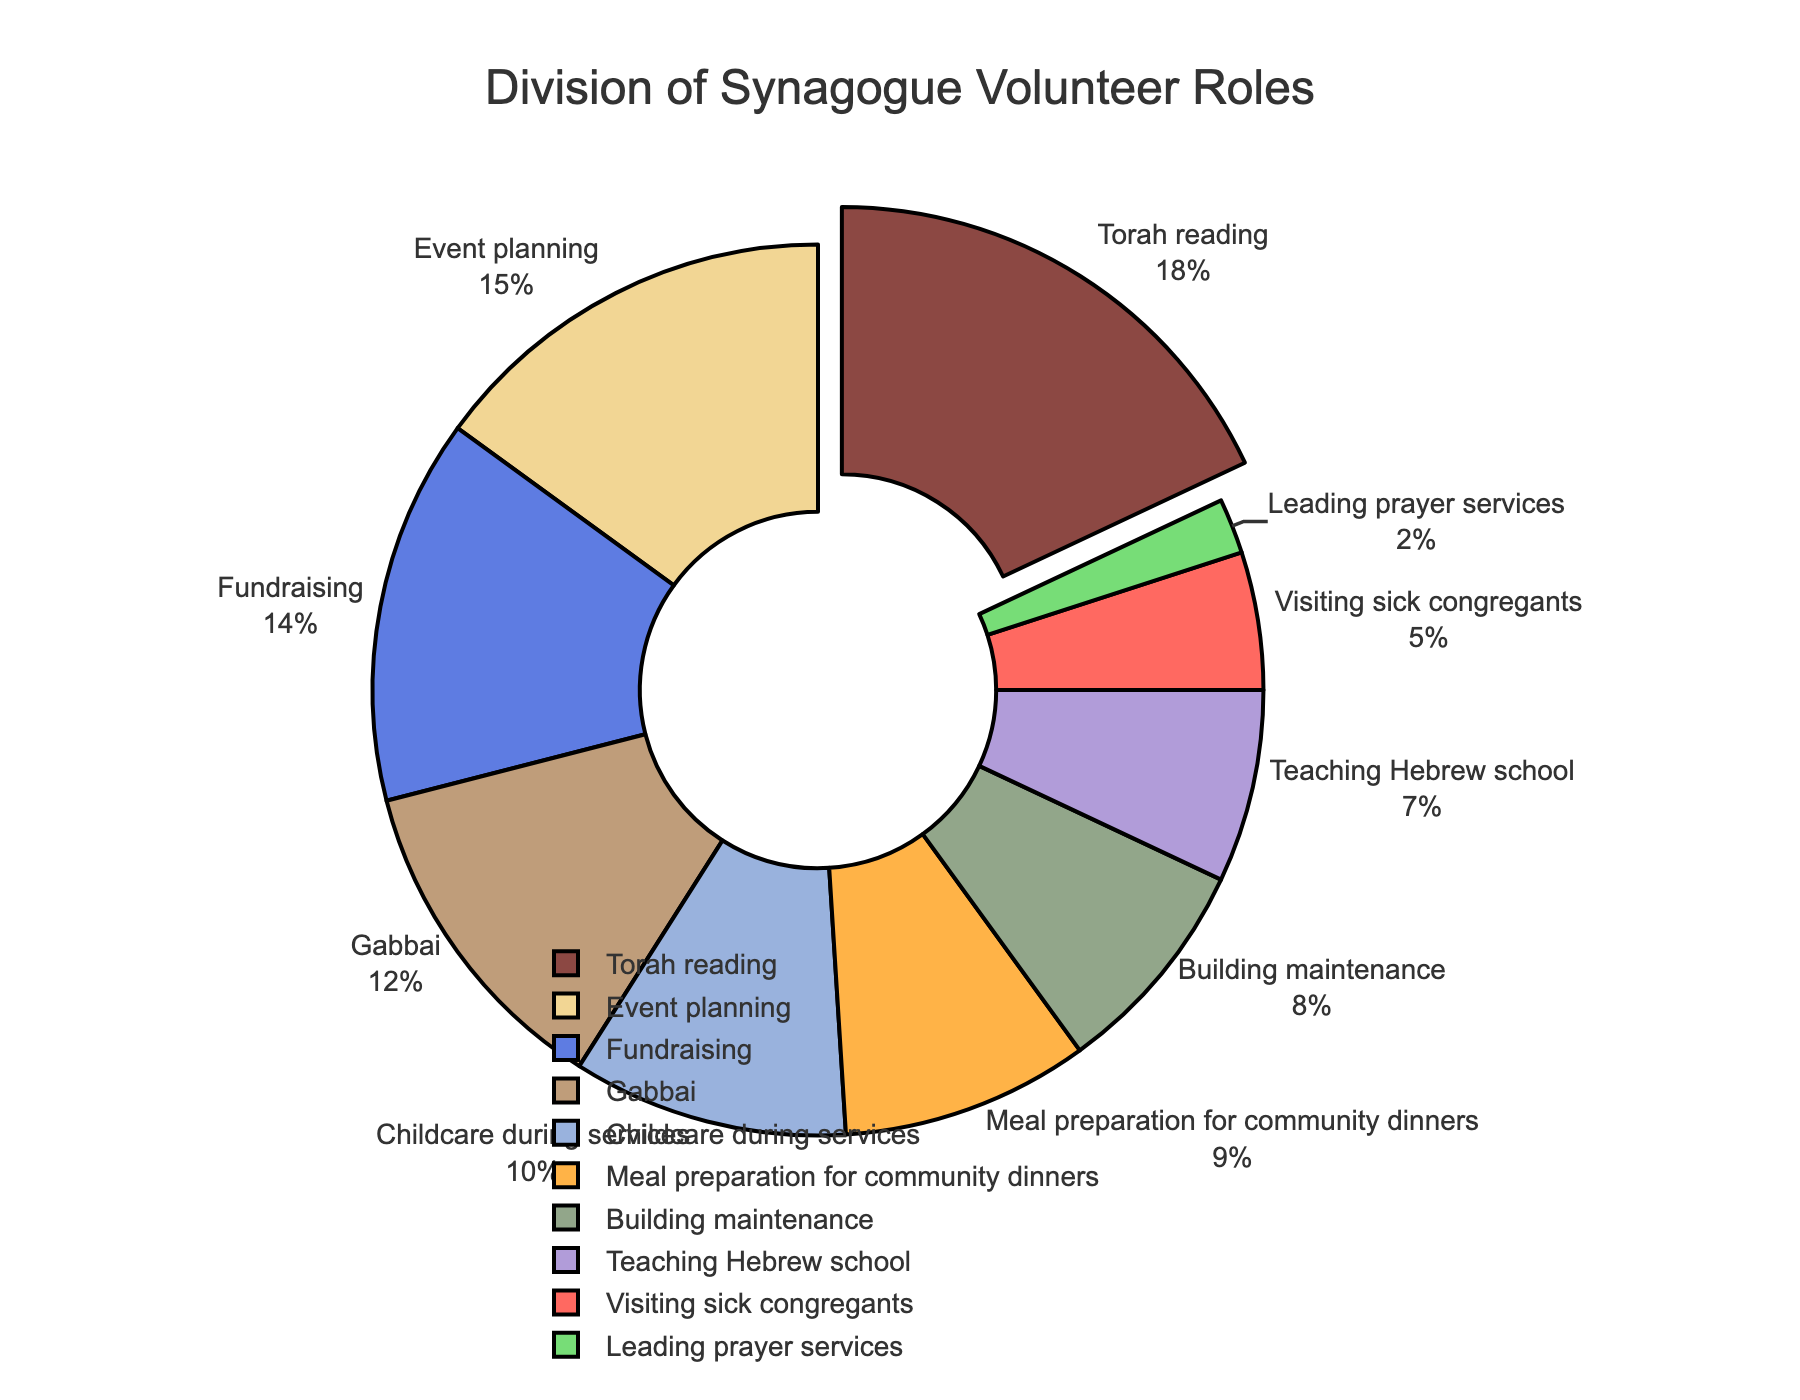What role has the highest percentage of volunteer participation? The segment with the largest pull-out in the pie chart represents the role with the highest percentage. In this case, it is Torah reading.
Answer: Torah reading What is the combined percentage of volunteers in Gabbai and Event planning? Add the percentages of Gabbai (12%) and Event planning (15%). 12 + 15 = 27
Answer: 27% Which role has the smallest slice in the pie chart, and what percentage does it represent? Identify the smallest visible slice in the pie chart, which corresponds to Leading prayer services. The percentage shown is 2%.
Answer: Leading prayer services, 2% Are there more volunteers in Fundraising or in Childcare during services? Compare the percentage segments of Fundraising (14%) and Childcare during services (10%). Fundraising has a higher percentage.
Answer: Fundraising What is the total percentage of volunteers in roles related to education (Teaching Hebrew school and Torah reading)? Add the percentages of Teaching Hebrew school (7%) and Torah reading (18%). 7 + 18 = 25
Answer: 25% Which roles together make up exactly 23% of the volunteer efforts? Identify the percentages of each role and sum them up to reach 23%. Meal preparation for community dinners (9%) + Teaching Hebrew school (7%) + Visiting sick congregants (5%) + Leading prayer services (2%) = 23%.
Answer: Meal preparation for community dinners, Teaching Hebrew school, Visiting sick congregants, Leading prayer services How much greater is the percentage of volunteers in Meal preparation for community dinners compared to Building maintenance? Subtract the percentage of Building maintenance (8%) from Meal preparation for community dinners (9%). 9 - 8 = 1
Answer: 1% Rank the top three volunteer roles based on their participation percentages. Identify the three largest segments in order: Torah reading (18%), Event planning (15%), and Fundraising (14%).
Answer: Torah reading, Event planning, Fundraising Do Building maintenance volunteers make up more or less than 10% of the total? Refer to the percentage for Building maintenance, which is 8%, and compare it to 10%.
Answer: Less What percentage of total volunteer efforts is dedicated to roles involving direct interaction with congregants (excluding administrative and event planning roles)? Sum the percentages of Torah reading (18%), Childcare during services (10%), Teaching Hebrew school (7%), Visiting sick congregants (5%), and Leading prayer services (2%). 18 + 10 + 7 + 5 + 2 = 42
Answer: 42% 